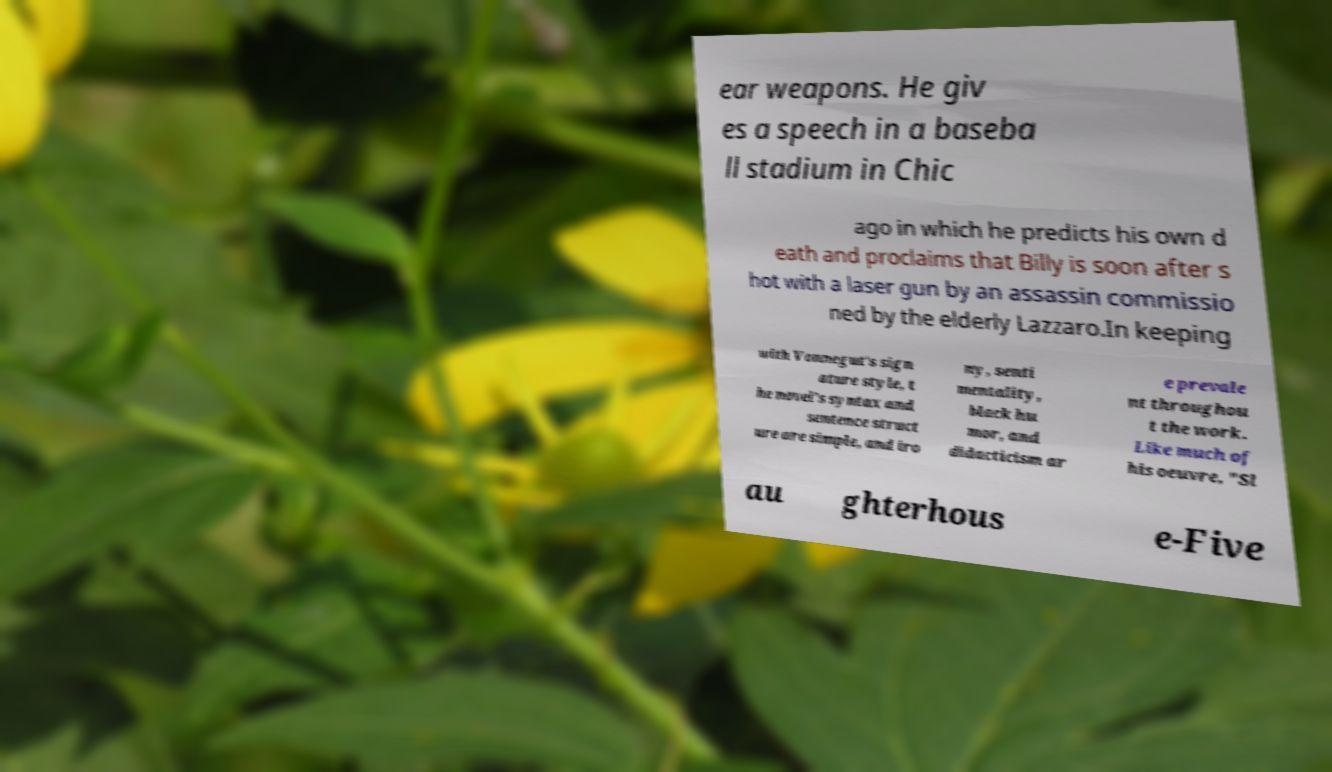For documentation purposes, I need the text within this image transcribed. Could you provide that? ear weapons. He giv es a speech in a baseba ll stadium in Chic ago in which he predicts his own d eath and proclaims that Billy is soon after s hot with a laser gun by an assassin commissio ned by the elderly Lazzaro.In keeping with Vonnegut's sign ature style, t he novel’s syntax and sentence struct ure are simple, and iro ny, senti mentality, black hu mor, and didacticism ar e prevale nt throughou t the work. Like much of his oeuvre, "Sl au ghterhous e-Five 